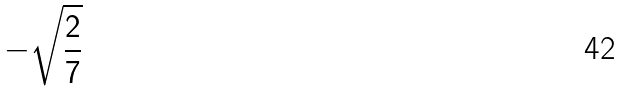Convert formula to latex. <formula><loc_0><loc_0><loc_500><loc_500>- \sqrt { \frac { 2 } { 7 } }</formula> 